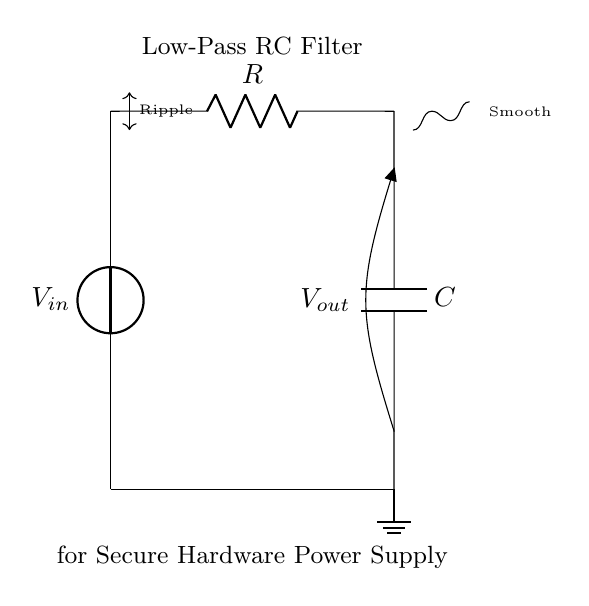What is the input voltage in this circuit? The input voltage is labeled as V_in in the circuit diagram, which typically represents the power supply voltage entering the circuit.
Answer: V_in What is the function of the resistor in this circuit? The resistor, labeled as R, is part of the low-pass filter configuration. It serves to limit the current to the capacitor and works with it to determine the cutoff frequency for the filter.
Answer: Limit current What is the role of the capacitor in a low-pass filter? The capacitor, labeled as C, stores charge and releases it to smooth out voltage variations, helping to reduce the ripple in the output voltage.
Answer: Smooth voltage What does the arrow indicating "Ripple" signify? The arrow labeled "Ripple" indicates the AC component or variations in the voltage supply (V_in) that the low-pass filter aims to attenuate or smooth out.
Answer: Voltage variations What type of filter is represented by this circuit? This circuit is a low-pass filter, designed to allow low-frequency signals to pass while attenuating higher-frequency noise or ripples.
Answer: Low-pass filter What does the "Smooth" curve indicate in the circuit output? The "Smooth" curve shows the expected output voltage behavior after filtering, demonstrating that it has less variation or ripple compared to the input.
Answer: Smoother output 